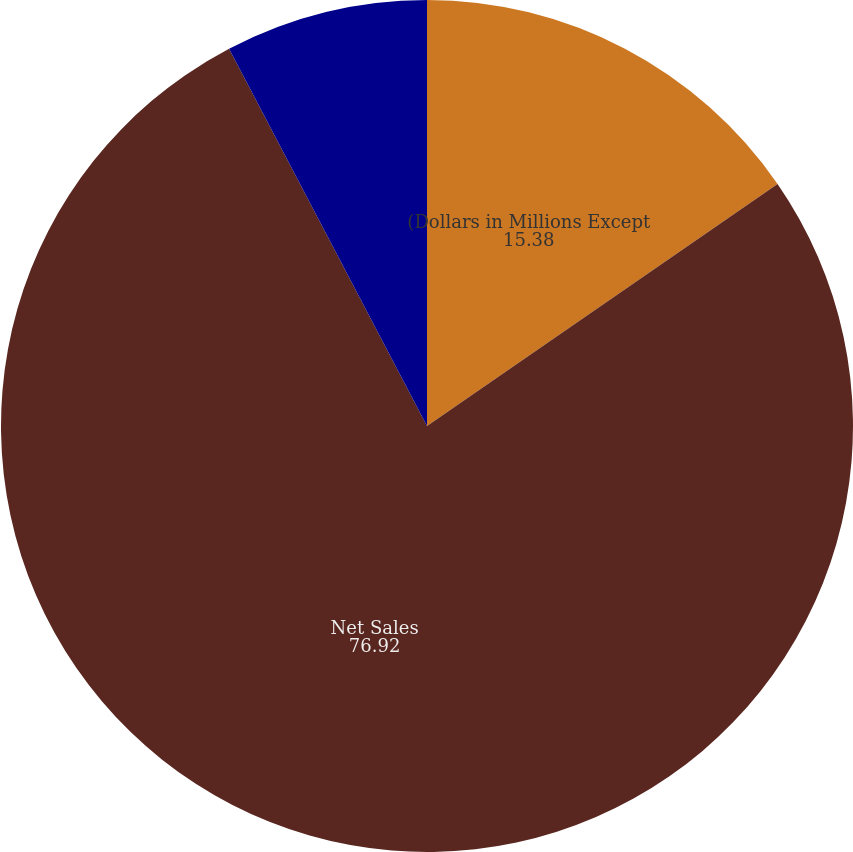<chart> <loc_0><loc_0><loc_500><loc_500><pie_chart><fcel>(Dollars in Millions Except<fcel>Net Sales<fcel>Net Earnings<fcel>Diluted Net Earnings per<nl><fcel>15.38%<fcel>76.92%<fcel>7.69%<fcel>0.0%<nl></chart> 